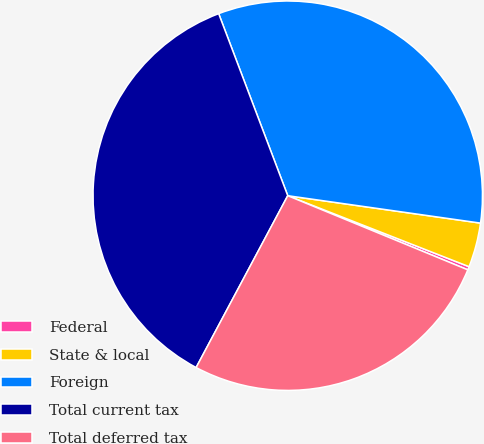Convert chart to OTSL. <chart><loc_0><loc_0><loc_500><loc_500><pie_chart><fcel>Federal<fcel>State & local<fcel>Foreign<fcel>Total current tax<fcel>Total deferred tax<nl><fcel>0.28%<fcel>3.69%<fcel>33.02%<fcel>36.43%<fcel>26.58%<nl></chart> 